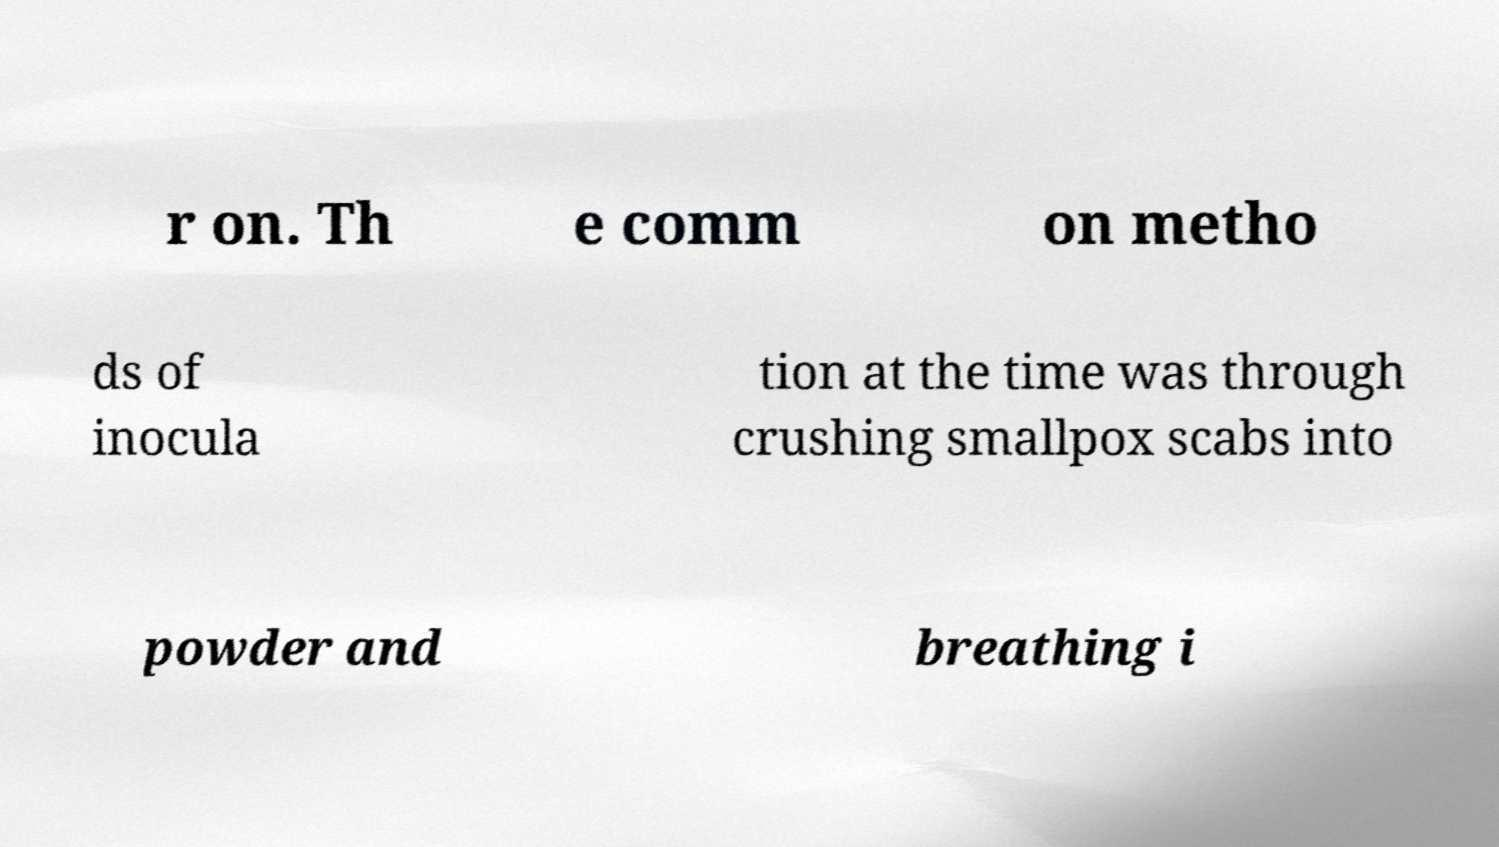Please read and relay the text visible in this image. What does it say? r on. Th e comm on metho ds of inocula tion at the time was through crushing smallpox scabs into powder and breathing i 